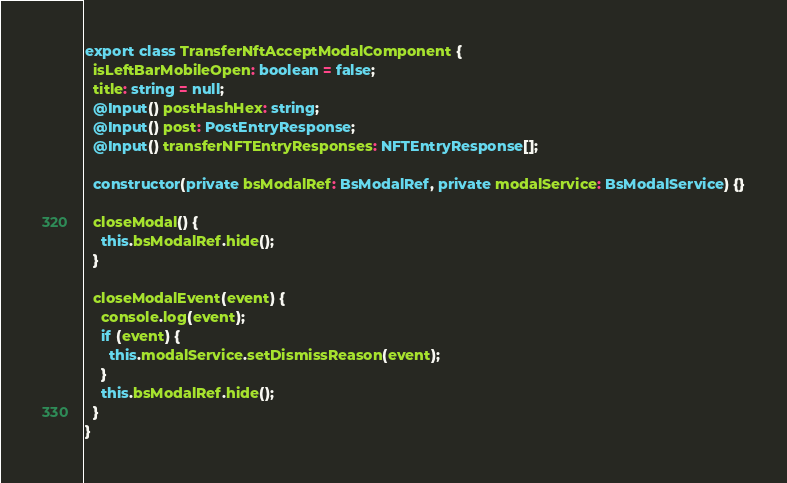<code> <loc_0><loc_0><loc_500><loc_500><_TypeScript_>export class TransferNftAcceptModalComponent {
  isLeftBarMobileOpen: boolean = false;
  title: string = null;
  @Input() postHashHex: string;
  @Input() post: PostEntryResponse;
  @Input() transferNFTEntryResponses: NFTEntryResponse[];

  constructor(private bsModalRef: BsModalRef, private modalService: BsModalService) {}

  closeModal() {
    this.bsModalRef.hide();
  }

  closeModalEvent(event) {
    console.log(event);
    if (event) {
      this.modalService.setDismissReason(event);
    }
    this.bsModalRef.hide();
  }
}
</code> 